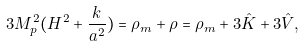<formula> <loc_0><loc_0><loc_500><loc_500>3 M ^ { 2 } _ { p } ( H ^ { 2 } + \frac { k } { a ^ { 2 } } ) = \rho _ { m } + \rho = \rho _ { m } + 3 \hat { K } + 3 \hat { V } ,</formula> 